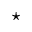Convert formula to latex. <formula><loc_0><loc_0><loc_500><loc_500>^ { ^ { * } }</formula> 